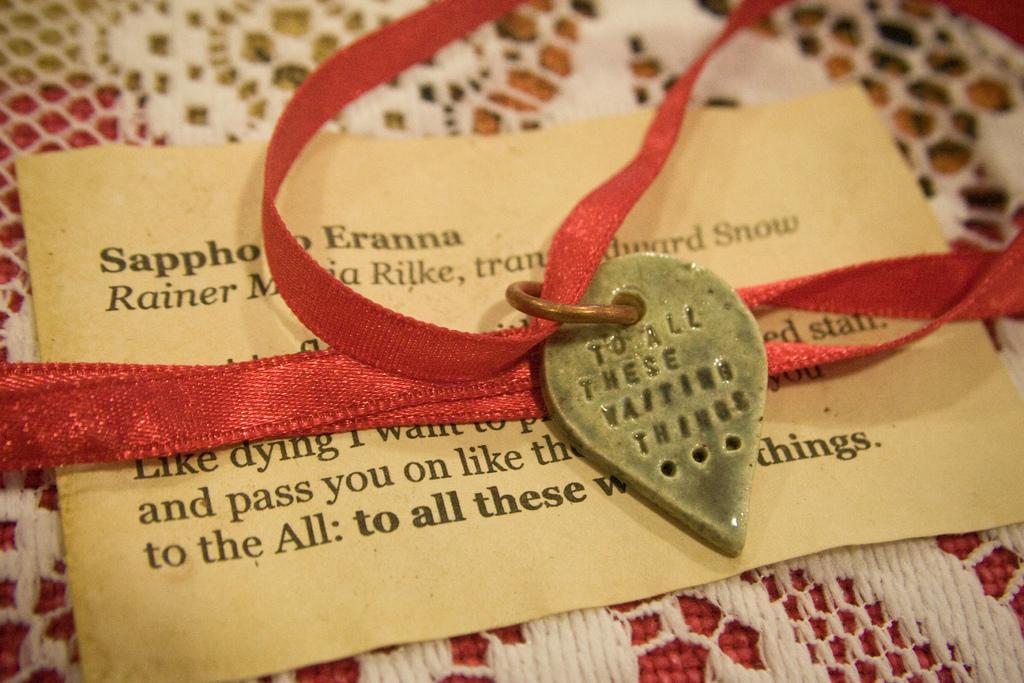Please provide a concise description of this image. In this image, we can see red ribbon with locked is placed on the paper. Here we can see some text. This paper is on the net cloth. 